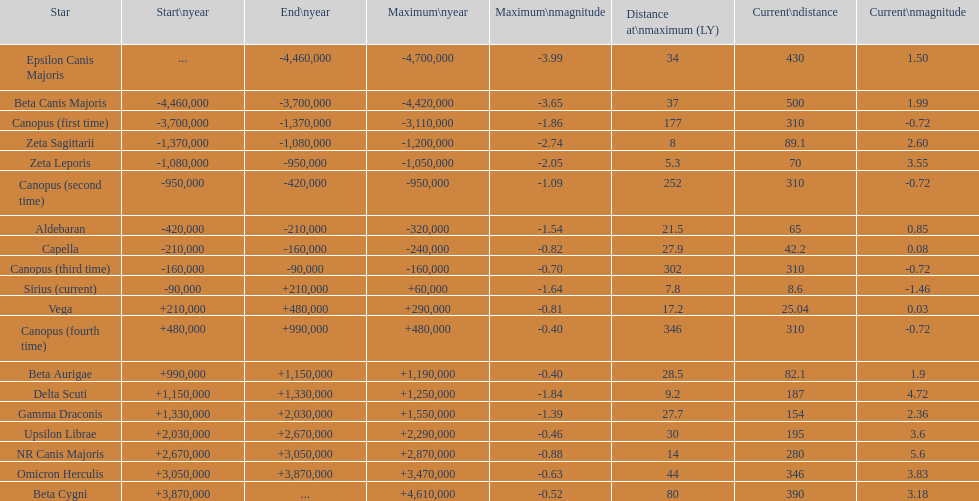How many stars maintain a current magnitude of at least 11. 